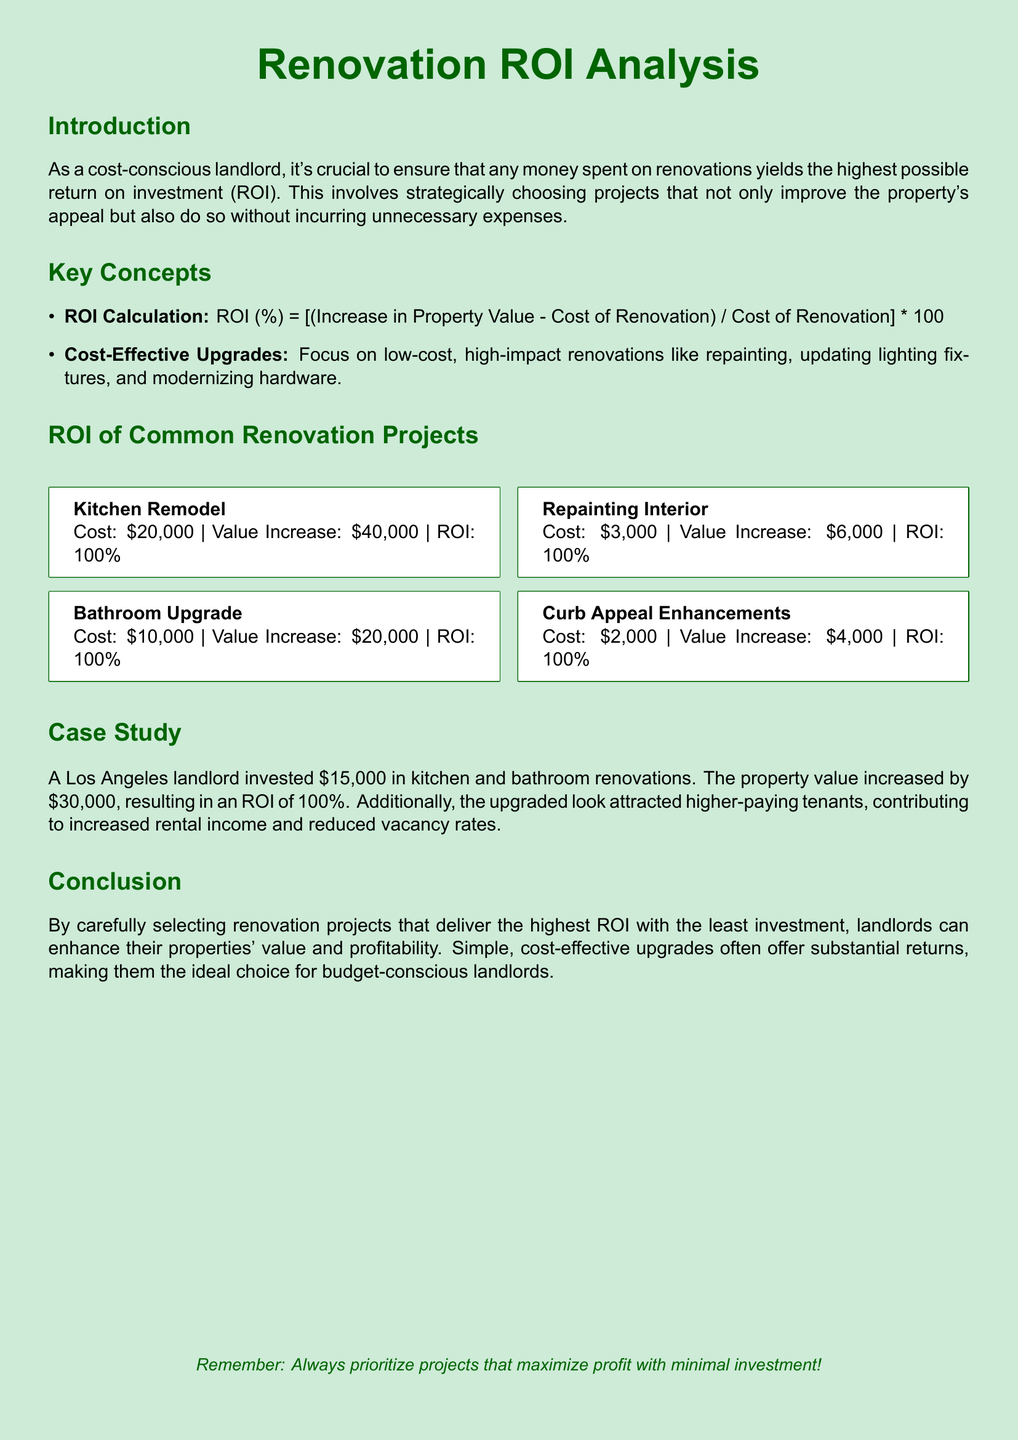How much did the kitchen remodel cost? The kitchen remodel cost is listed in the ROI of Common Renovation Projects section.
Answer: $20,000 What is the value increase of the bathroom upgrade? The bathroom upgrade's value increase is stated in the ROI of Common Renovation Projects section.
Answer: $20,000 What is the ROI percentage for repainting the interior? The ROI percentage for repainting the interior is calculated in the document and displayed accordingly.
Answer: 100% What renovation project has the lowest cost? The lowest cost renovation project can be found in the ROI of Common Renovation Projects section.
Answer: Curb Appeal Enhancements What was the total investment in the case study? The total investment mentioned in the case study includes the kitchen and bathroom renovations.
Answer: $15,000 What is the main priority for budget-conscious landlords? The conclusion of the document highlights the main priority for landlords.
Answer: Maximize profit with minimal investment What is the value increase of curb appeal enhancements? The document provides a specific value increase for curb appeal enhancements under the ROI of Common Renovation Projects section.
Answer: $4,000 What type of upgrades are emphasized as cost-effective? The document lists specific types of upgrades that are mentioned as cost-effective in the Key Concepts section.
Answer: Low-cost, high-impact renovations 